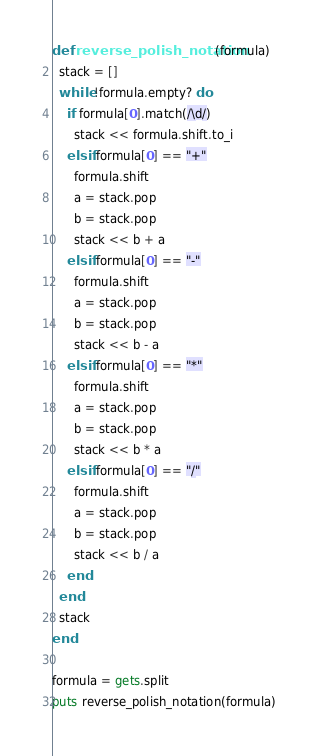<code> <loc_0><loc_0><loc_500><loc_500><_Ruby_>def reverse_polish_notation(formula)
  stack = []
  while !formula.empty? do
    if formula[0].match(/\d/)
      stack << formula.shift.to_i
    elsif formula[0] == "+"
      formula.shift
      a = stack.pop
      b = stack.pop
      stack << b + a
    elsif formula[0] == "-"
      formula.shift
      a = stack.pop
      b = stack.pop
      stack << b - a
    elsif formula[0] == "*"
      formula.shift
      a = stack.pop
      b = stack.pop
      stack << b * a
    elsif formula[0] == "/"
      formula.shift
      a = stack.pop
      b = stack.pop
      stack << b / a
    end
  end
  stack
end

formula = gets.split
puts reverse_polish_notation(formula)

</code> 